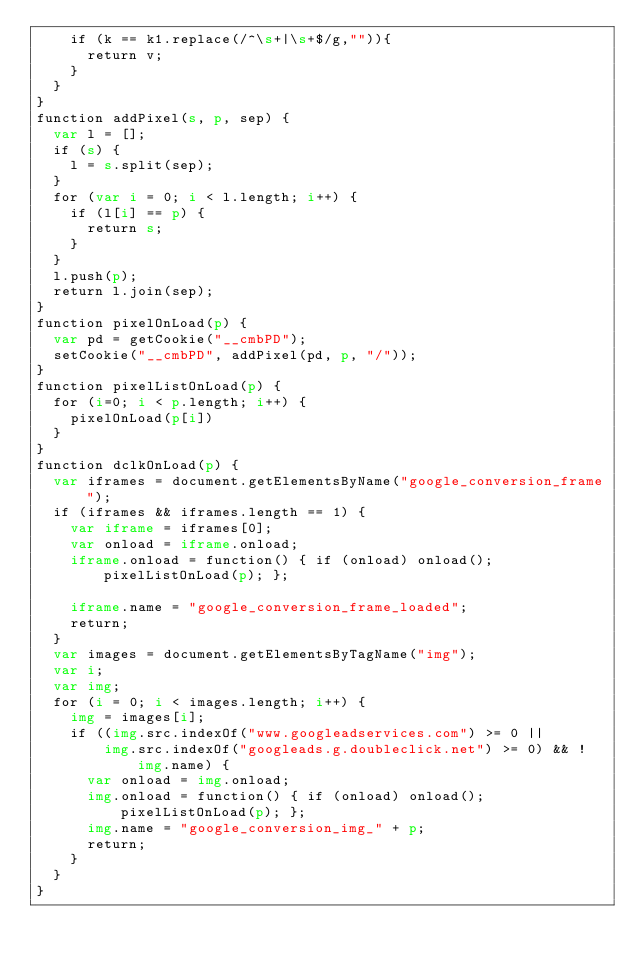Convert code to text. <code><loc_0><loc_0><loc_500><loc_500><_HTML_>    if (k == k1.replace(/^\s+|\s+$/g,"")){
      return v;
    }
  }
}
function addPixel(s, p, sep) {
  var l = [];
  if (s) {
    l = s.split(sep);
  }
  for (var i = 0; i < l.length; i++) {
    if (l[i] == p) {
      return s;
    }
  }
  l.push(p);
  return l.join(sep);
}
function pixelOnLoad(p) {
  var pd = getCookie("__cmbPD");
  setCookie("__cmbPD", addPixel(pd, p, "/"));
}
function pixelListOnLoad(p) {
  for (i=0; i < p.length; i++) {
    pixelOnLoad(p[i])
  }
}
function dclkOnLoad(p) {
  var iframes = document.getElementsByName("google_conversion_frame");
  if (iframes && iframes.length == 1) {
    var iframe = iframes[0];
    var onload = iframe.onload;
    iframe.onload = function() { if (onload) onload(); pixelListOnLoad(p); };

    iframe.name = "google_conversion_frame_loaded";
    return;
  }
  var images = document.getElementsByTagName("img");
  var i;
  var img;
  for (i = 0; i < images.length; i++) {
    img = images[i];
    if ((img.src.indexOf("www.googleadservices.com") >= 0 ||
        img.src.indexOf("googleads.g.doubleclick.net") >= 0) && !img.name) {
      var onload = img.onload;
      img.onload = function() { if (onload) onload(); pixelListOnLoad(p); };
      img.name = "google_conversion_img_" + p;
      return;
    }
  }
}
</code> 